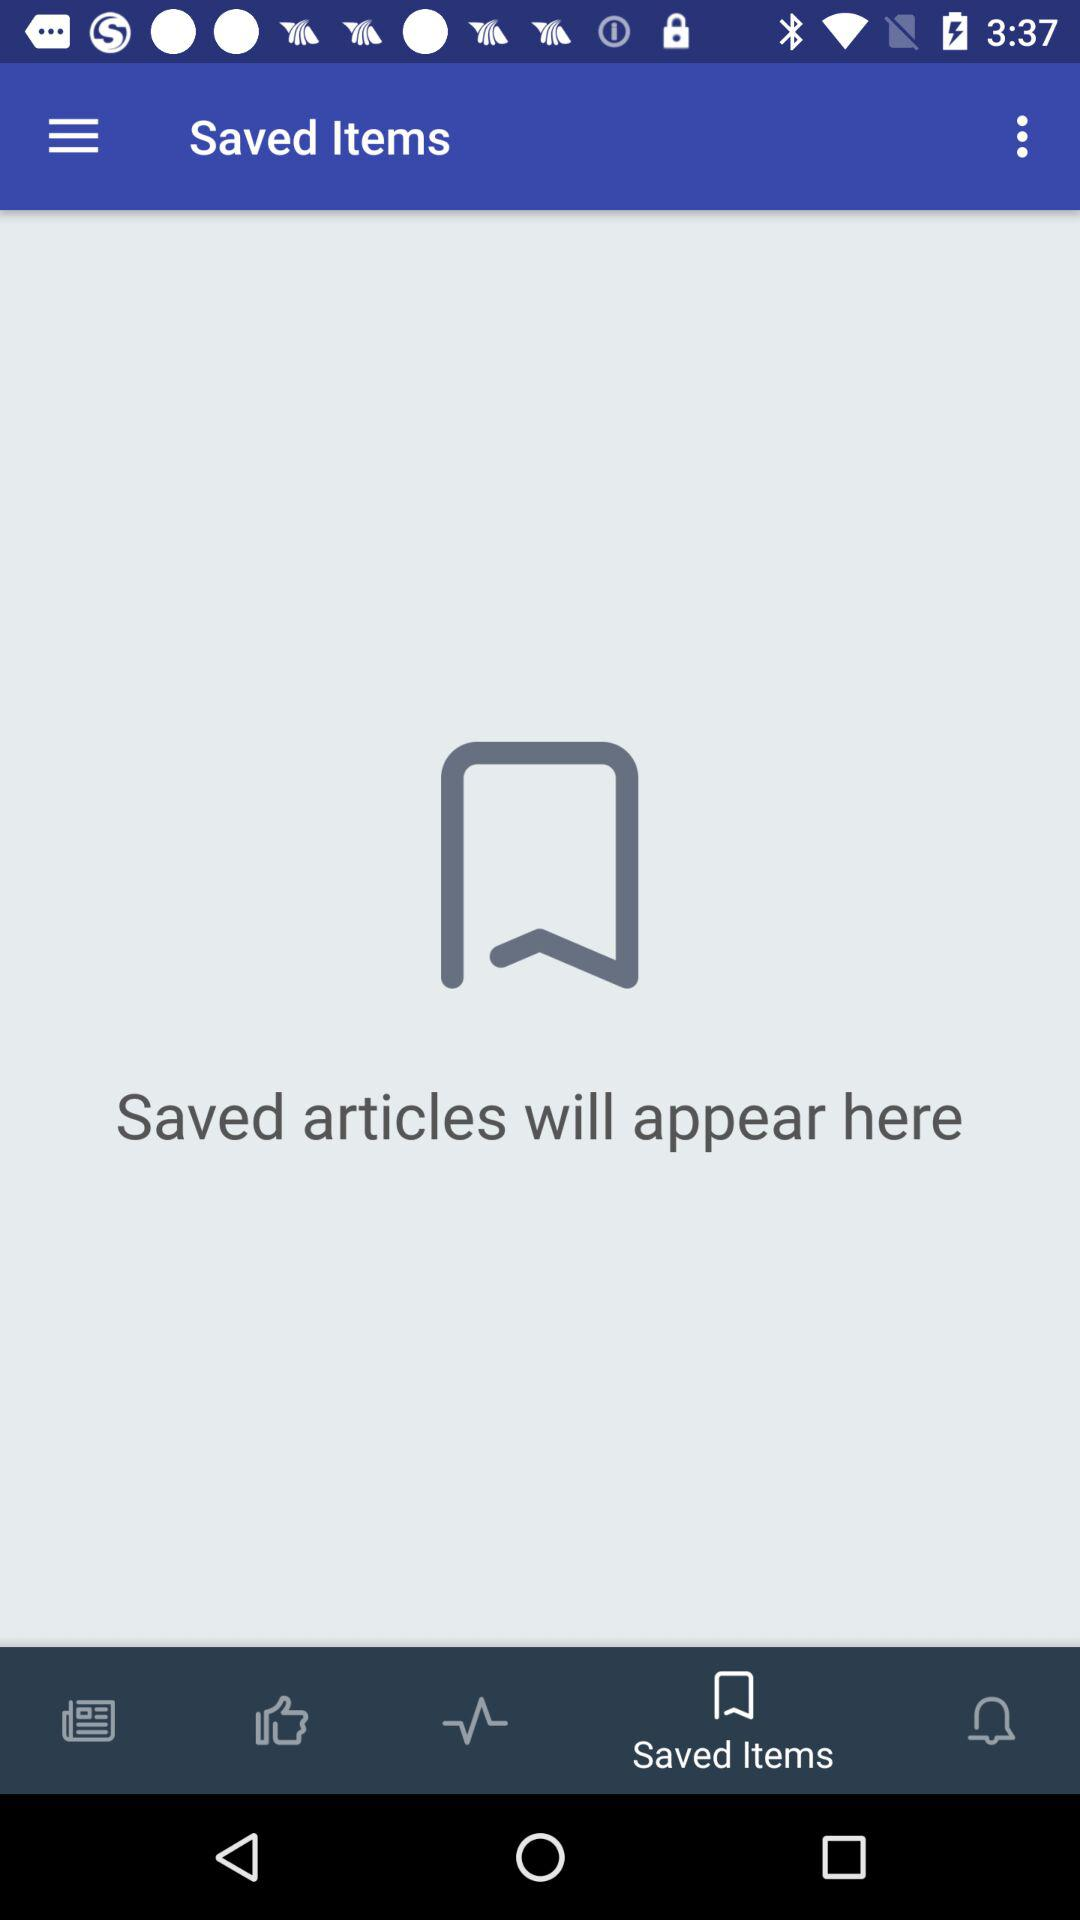In which tab will the saved articles be shown? The tab is "Saved Items". 